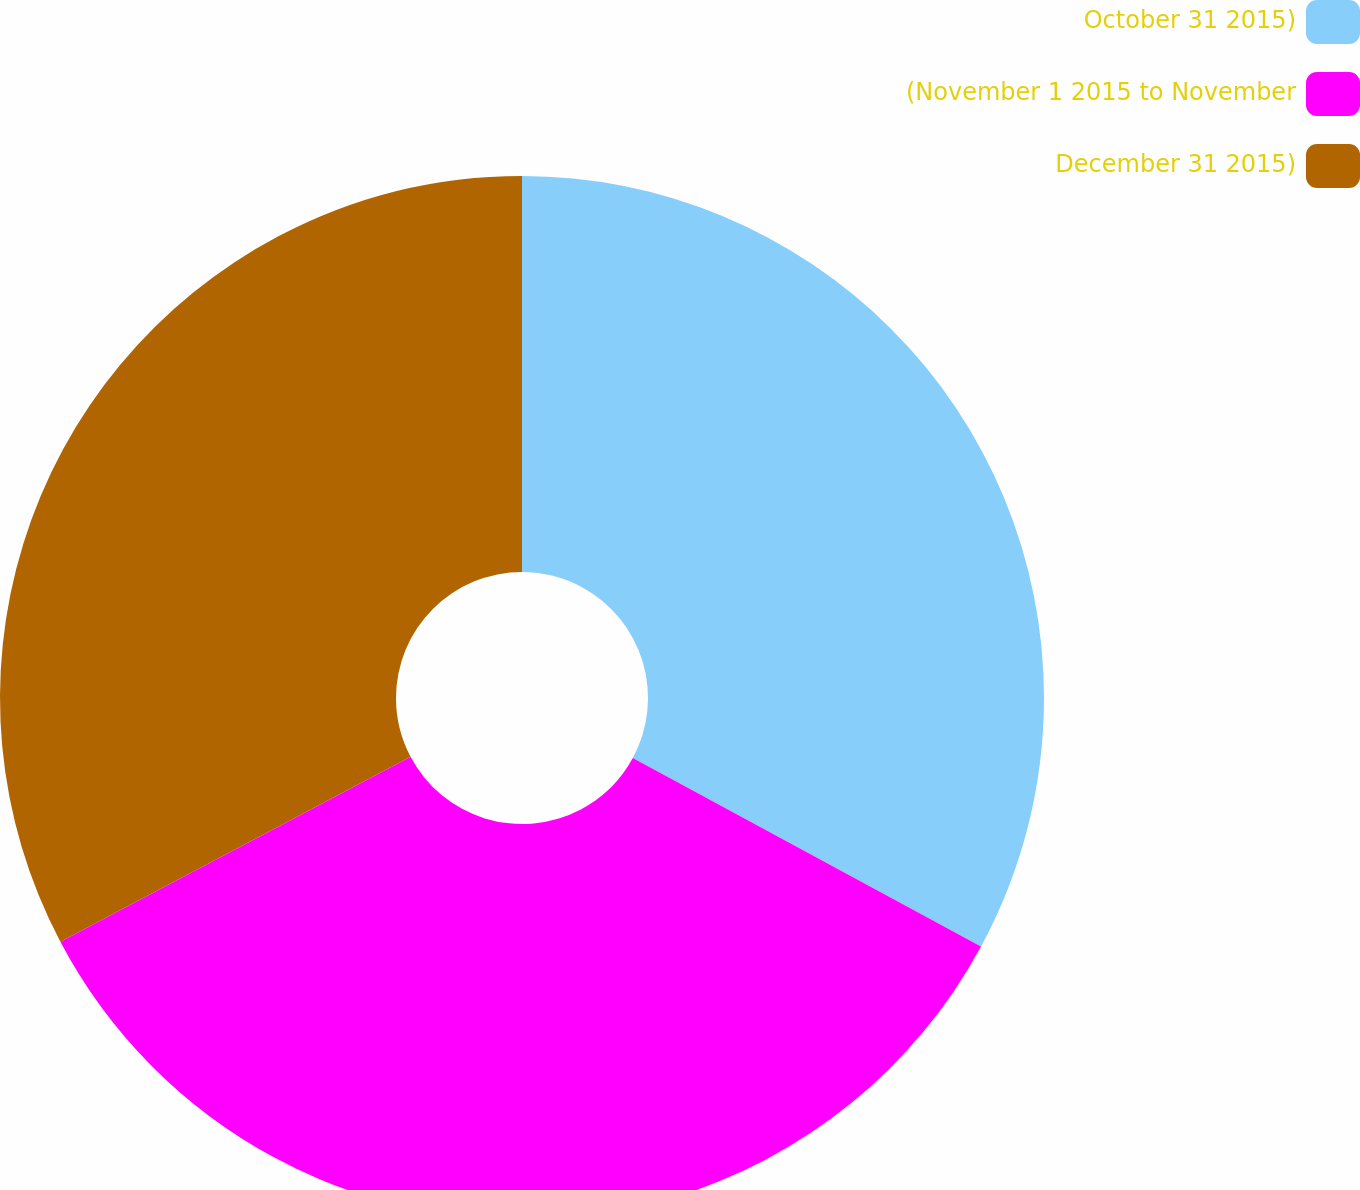<chart> <loc_0><loc_0><loc_500><loc_500><pie_chart><fcel>October 31 2015)<fcel>(November 1 2015 to November<fcel>December 31 2015)<nl><fcel>32.9%<fcel>34.37%<fcel>32.73%<nl></chart> 